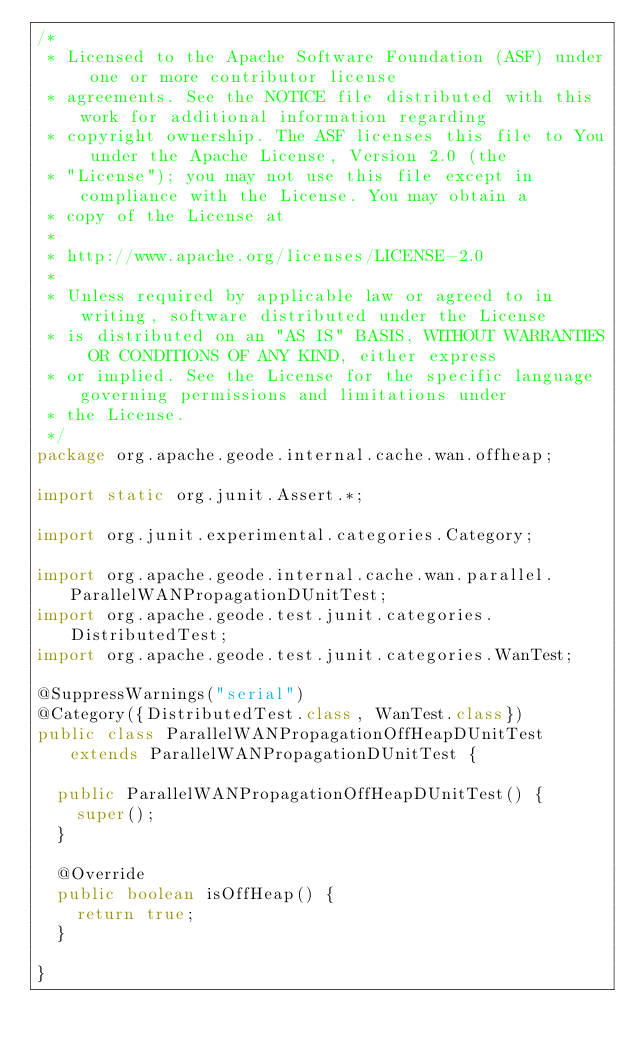Convert code to text. <code><loc_0><loc_0><loc_500><loc_500><_Java_>/*
 * Licensed to the Apache Software Foundation (ASF) under one or more contributor license
 * agreements. See the NOTICE file distributed with this work for additional information regarding
 * copyright ownership. The ASF licenses this file to You under the Apache License, Version 2.0 (the
 * "License"); you may not use this file except in compliance with the License. You may obtain a
 * copy of the License at
 *
 * http://www.apache.org/licenses/LICENSE-2.0
 *
 * Unless required by applicable law or agreed to in writing, software distributed under the License
 * is distributed on an "AS IS" BASIS, WITHOUT WARRANTIES OR CONDITIONS OF ANY KIND, either express
 * or implied. See the License for the specific language governing permissions and limitations under
 * the License.
 */
package org.apache.geode.internal.cache.wan.offheap;

import static org.junit.Assert.*;

import org.junit.experimental.categories.Category;

import org.apache.geode.internal.cache.wan.parallel.ParallelWANPropagationDUnitTest;
import org.apache.geode.test.junit.categories.DistributedTest;
import org.apache.geode.test.junit.categories.WanTest;

@SuppressWarnings("serial")
@Category({DistributedTest.class, WanTest.class})
public class ParallelWANPropagationOffHeapDUnitTest extends ParallelWANPropagationDUnitTest {

  public ParallelWANPropagationOffHeapDUnitTest() {
    super();
  }

  @Override
  public boolean isOffHeap() {
    return true;
  }

}
</code> 